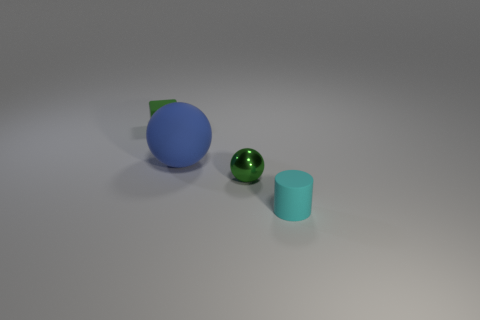Are there an equal number of rubber balls that are behind the small cylinder and small rubber blocks that are right of the green metallic sphere?
Keep it short and to the point. No. There is a small cylinder that is made of the same material as the large blue thing; what is its color?
Offer a very short reply. Cyan. Do the matte cylinder and the small matte thing on the left side of the green shiny ball have the same color?
Your answer should be very brief. No. Are there any green shiny things that are behind the tiny green thing to the right of the sphere on the left side of the small metal sphere?
Your response must be concise. No. What is the shape of the blue thing that is the same material as the small cyan cylinder?
Provide a short and direct response. Sphere. Is there any other thing that has the same shape as the green shiny object?
Provide a short and direct response. Yes. What is the shape of the small green metal object?
Your answer should be compact. Sphere. Is the shape of the small matte object behind the green ball the same as  the cyan matte thing?
Make the answer very short. No. Are there more blue spheres to the right of the metallic thing than rubber cylinders that are to the left of the large ball?
Make the answer very short. No. How many other objects are there of the same size as the cyan matte cylinder?
Provide a succinct answer. 2. 